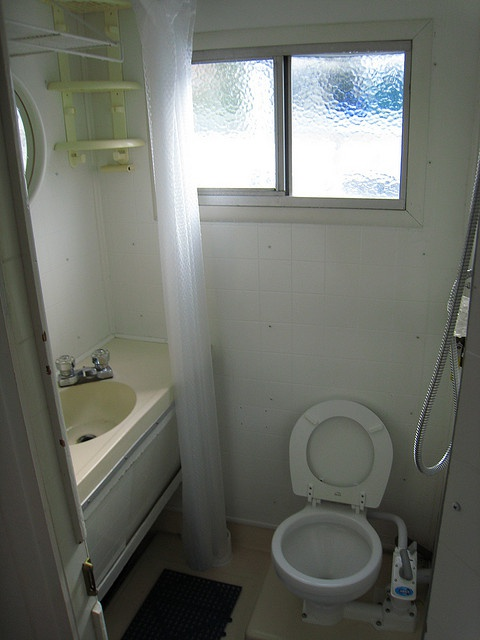Describe the objects in this image and their specific colors. I can see toilet in black and gray tones and sink in black, gray, and darkgray tones in this image. 